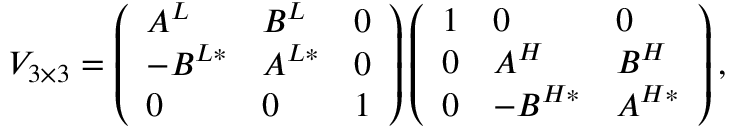<formula> <loc_0><loc_0><loc_500><loc_500>V _ { 3 \times 3 } = \left ( \begin{array} { l l l } { { A ^ { L } } } & { { B ^ { L } } } & { 0 } \\ { { - B ^ { L * } } } & { { A ^ { L * } } } & { 0 } \\ { 0 } & { 0 } & { 1 } \end{array} \right ) \left ( \begin{array} { l l l } { 1 } & { 0 } & { 0 } \\ { 0 } & { { A ^ { H } } } & { { B ^ { H } } } \\ { 0 } & { { - B ^ { H * } } } & { { A ^ { H * } } } \end{array} \right ) ,</formula> 